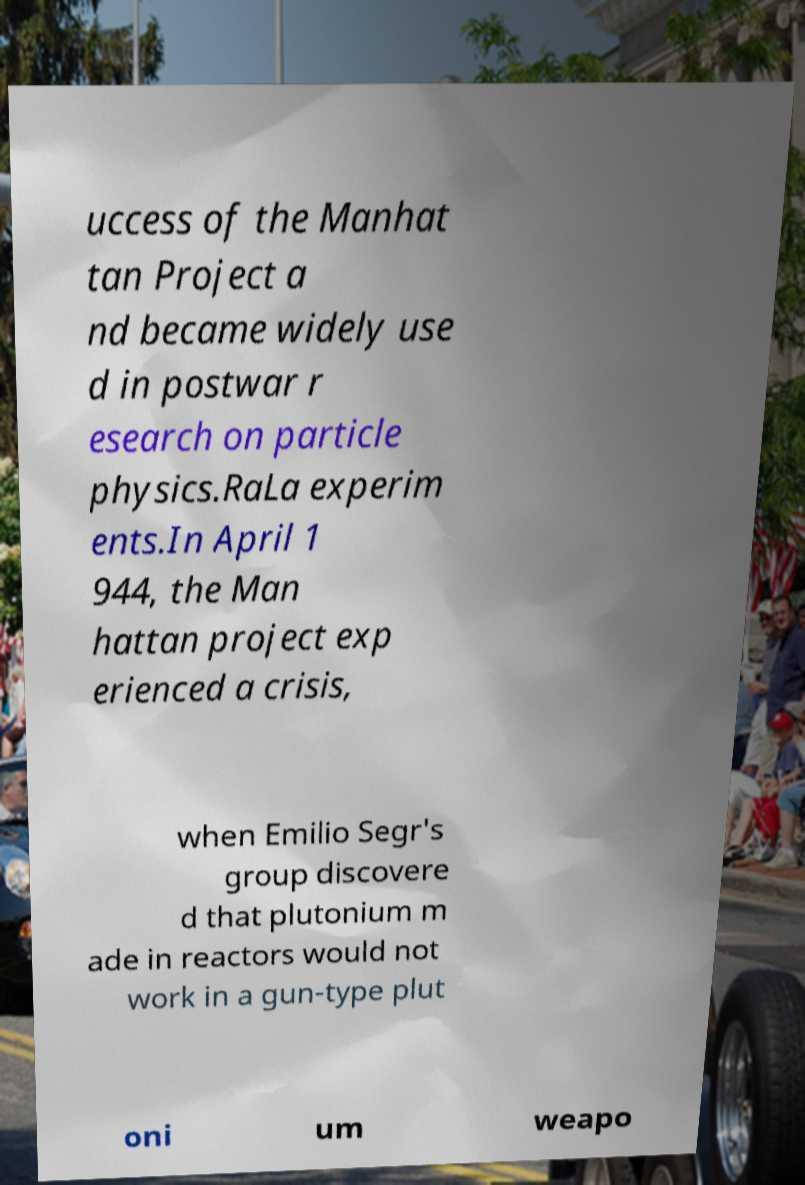Could you extract and type out the text from this image? uccess of the Manhat tan Project a nd became widely use d in postwar r esearch on particle physics.RaLa experim ents.In April 1 944, the Man hattan project exp erienced a crisis, when Emilio Segr's group discovere d that plutonium m ade in reactors would not work in a gun-type plut oni um weapo 